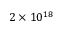<formula> <loc_0><loc_0><loc_500><loc_500>2 \times 1 0 ^ { 1 8 }</formula> 